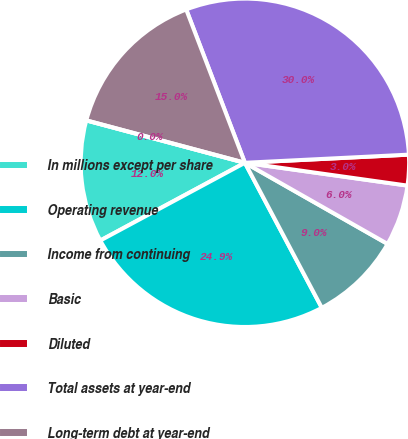Convert chart. <chart><loc_0><loc_0><loc_500><loc_500><pie_chart><fcel>In millions except per share<fcel>Operating revenue<fcel>Income from continuing<fcel>Basic<fcel>Diluted<fcel>Total assets at year-end<fcel>Long-term debt at year-end<fcel>Cash dividends declared per<nl><fcel>12.01%<fcel>24.91%<fcel>9.01%<fcel>6.01%<fcel>3.01%<fcel>30.03%<fcel>15.02%<fcel>0.0%<nl></chart> 